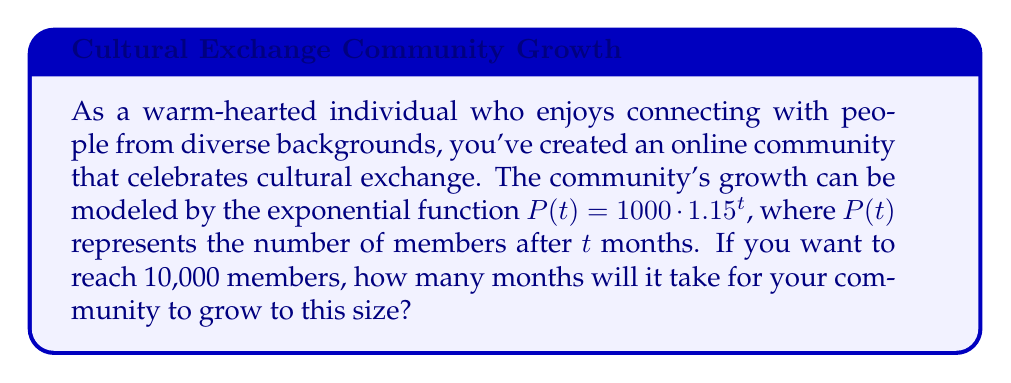Show me your answer to this math problem. To solve this problem, we need to use the properties of exponential functions and logarithms. Let's approach this step-by-step:

1) We start with the given exponential function:
   $P(t) = 1000 \cdot 1.15^t$

2) We want to find $t$ when $P(t) = 10000$. So, we set up the equation:
   $10000 = 1000 \cdot 1.15^t$

3) Divide both sides by 1000:
   $10 = 1.15^t$

4) To solve for $t$, we need to take the logarithm of both sides. We can use any base, but the natural log (ln) is often convenient:
   $\ln(10) = \ln(1.15^t)$

5) Using the logarithm property $\ln(a^b) = b\ln(a)$, we get:
   $\ln(10) = t \cdot \ln(1.15)$

6) Now we can solve for $t$:
   $t = \frac{\ln(10)}{\ln(1.15)}$

7) Using a calculator to evaluate this:
   $t \approx 16.27$ months

8) Since we can't have a fractional month in this context, we need to round up to the next whole month.
Answer: It will take 17 months for the online community to reach 10,000 members. 